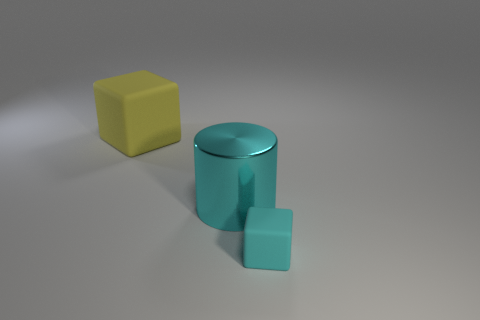Add 1 cyan things. How many objects exist? 4 Subtract all cyan blocks. How many blocks are left? 1 Subtract all blocks. How many objects are left? 1 Subtract all cyan blocks. Subtract all red balls. How many blocks are left? 1 Subtract all cyan cylinders. How many cyan blocks are left? 1 Subtract all rubber objects. Subtract all tiny blocks. How many objects are left? 0 Add 1 cylinders. How many cylinders are left? 2 Add 1 large metal objects. How many large metal objects exist? 2 Subtract 0 gray cubes. How many objects are left? 3 Subtract 1 cylinders. How many cylinders are left? 0 